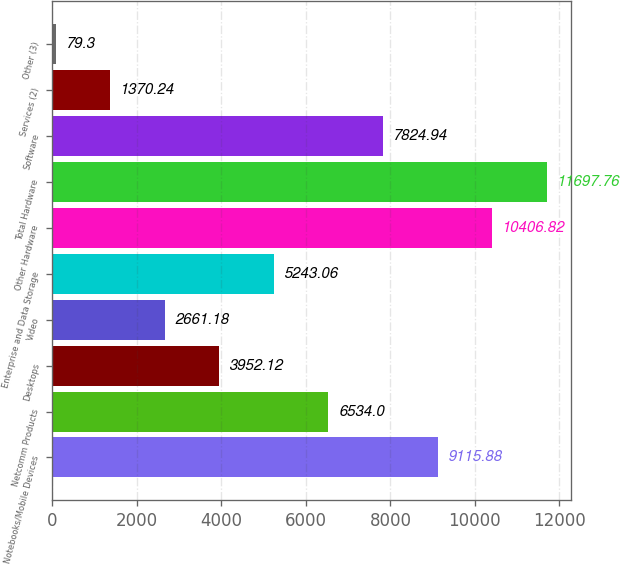Convert chart to OTSL. <chart><loc_0><loc_0><loc_500><loc_500><bar_chart><fcel>Notebooks/Mobile Devices<fcel>Netcomm Products<fcel>Desktops<fcel>Video<fcel>Enterprise and Data Storage<fcel>Other Hardware<fcel>Total Hardware<fcel>Software<fcel>Services (2)<fcel>Other (3)<nl><fcel>9115.88<fcel>6534<fcel>3952.12<fcel>2661.18<fcel>5243.06<fcel>10406.8<fcel>11697.8<fcel>7824.94<fcel>1370.24<fcel>79.3<nl></chart> 